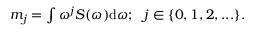<formula> <loc_0><loc_0><loc_500><loc_500>\begin{array} { r } { m _ { j } = \int \omega ^ { j } S ( \omega ) d \omega ; j \in \{ 0 , 1 , 2 , \dots \} . } \end{array}</formula> 